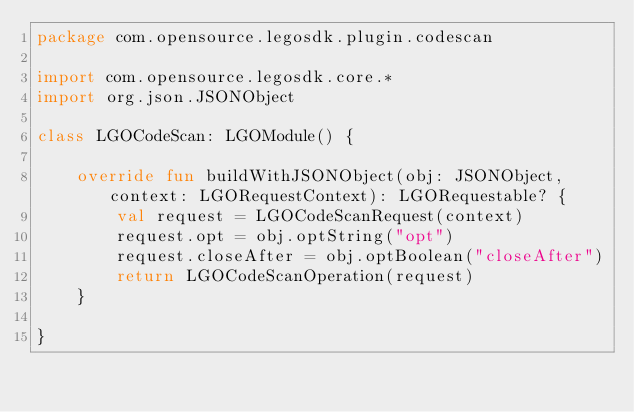<code> <loc_0><loc_0><loc_500><loc_500><_Kotlin_>package com.opensource.legosdk.plugin.codescan

import com.opensource.legosdk.core.*
import org.json.JSONObject

class LGOCodeScan: LGOModule() {

    override fun buildWithJSONObject(obj: JSONObject, context: LGORequestContext): LGORequestable? {
        val request = LGOCodeScanRequest(context)
        request.opt = obj.optString("opt")
        request.closeAfter = obj.optBoolean("closeAfter")
        return LGOCodeScanOperation(request)
    }

}</code> 